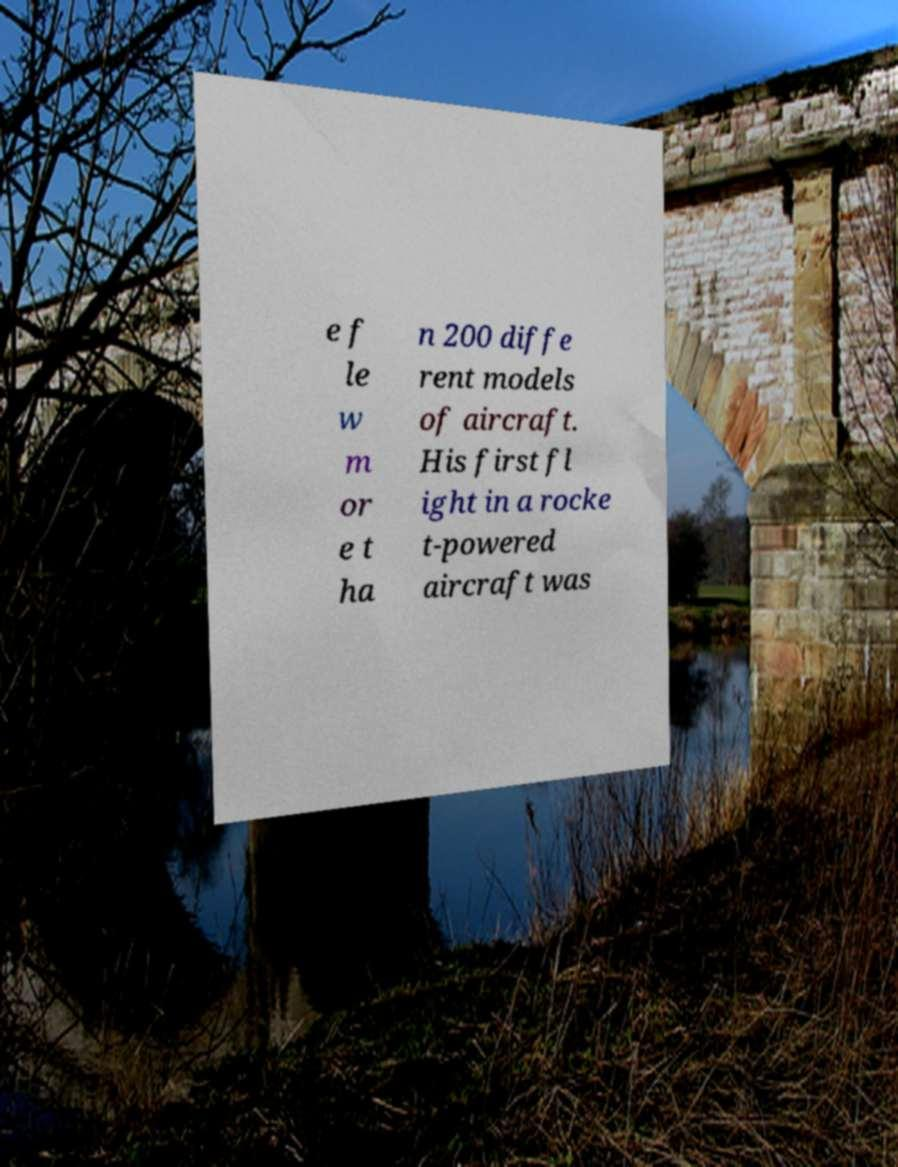Please read and relay the text visible in this image. What does it say? e f le w m or e t ha n 200 diffe rent models of aircraft. His first fl ight in a rocke t-powered aircraft was 